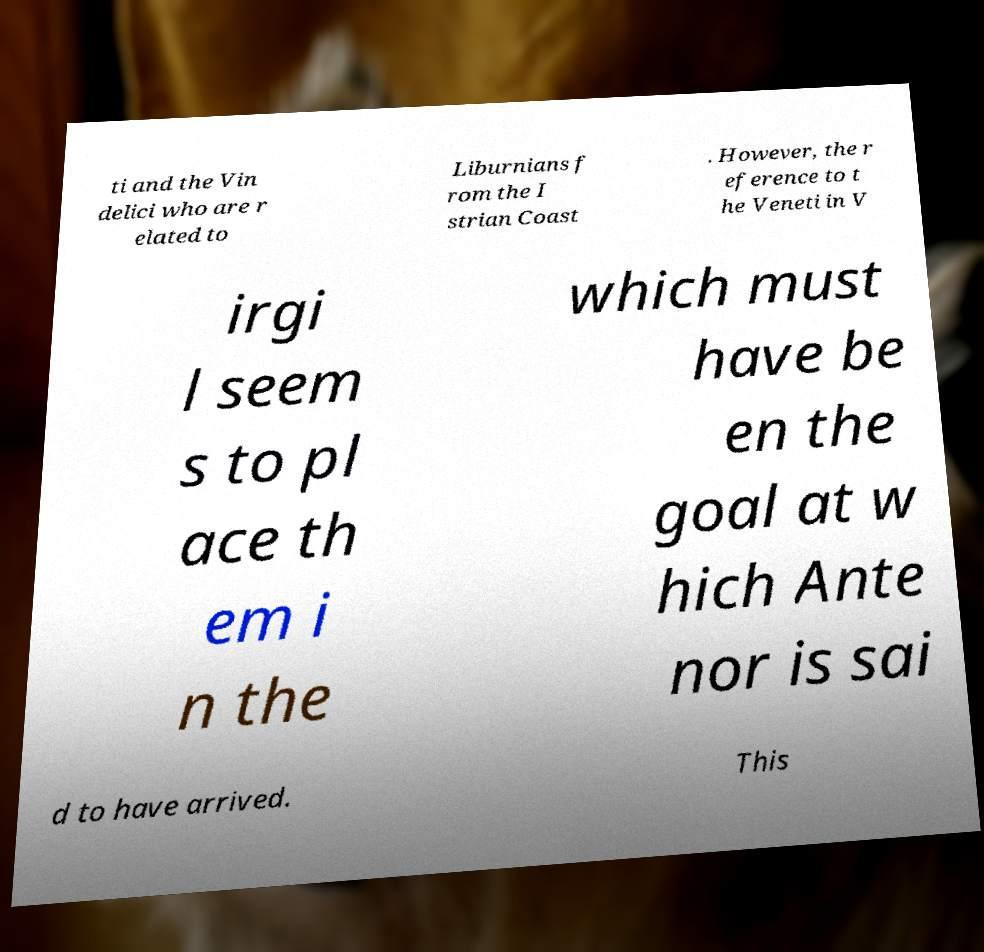Could you extract and type out the text from this image? ti and the Vin delici who are r elated to Liburnians f rom the I strian Coast . However, the r eference to t he Veneti in V irgi l seem s to pl ace th em i n the which must have be en the goal at w hich Ante nor is sai d to have arrived. This 